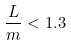Convert formula to latex. <formula><loc_0><loc_0><loc_500><loc_500>\frac { L } { m } < 1 . 3</formula> 